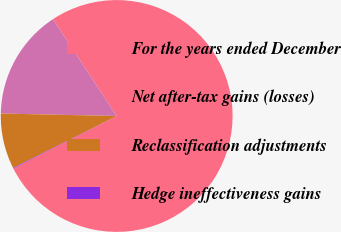Convert chart to OTSL. <chart><loc_0><loc_0><loc_500><loc_500><pie_chart><fcel>For the years ended December<fcel>Net after-tax gains (losses)<fcel>Reclassification adjustments<fcel>Hedge ineffectiveness gains<nl><fcel>76.76%<fcel>15.41%<fcel>7.75%<fcel>0.08%<nl></chart> 